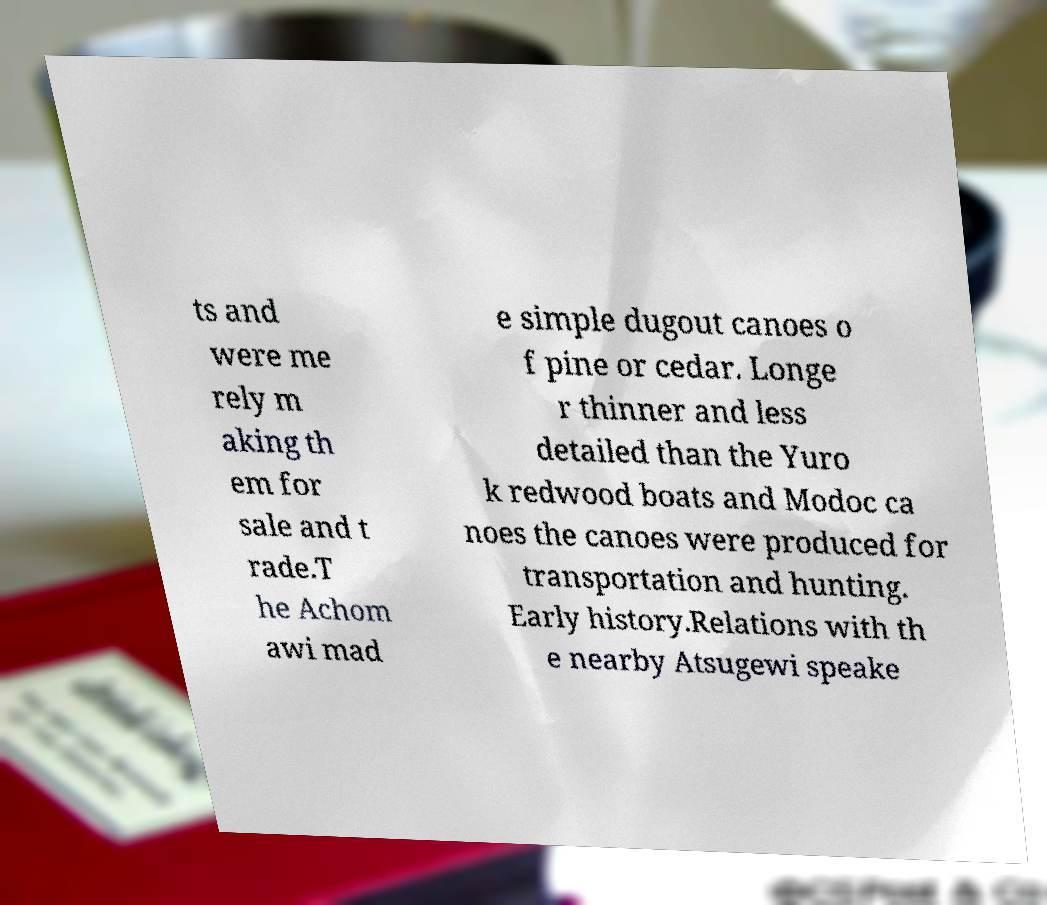There's text embedded in this image that I need extracted. Can you transcribe it verbatim? ts and were me rely m aking th em for sale and t rade.T he Achom awi mad e simple dugout canoes o f pine or cedar. Longe r thinner and less detailed than the Yuro k redwood boats and Modoc ca noes the canoes were produced for transportation and hunting. Early history.Relations with th e nearby Atsugewi speake 